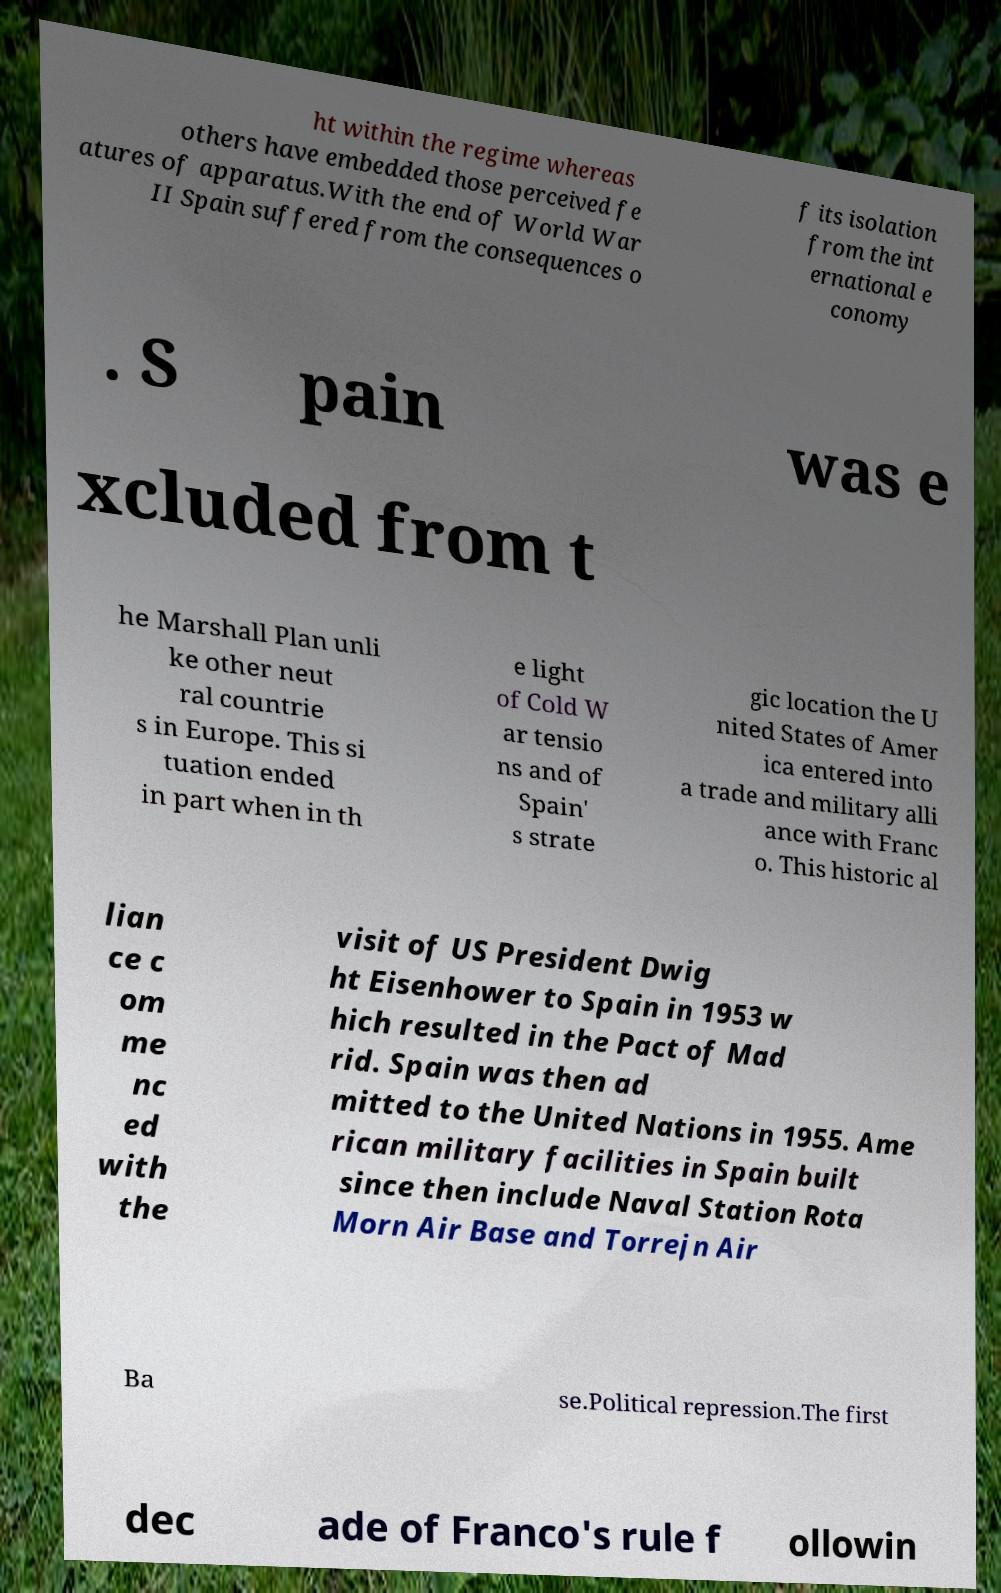Can you read and provide the text displayed in the image?This photo seems to have some interesting text. Can you extract and type it out for me? ht within the regime whereas others have embedded those perceived fe atures of apparatus.With the end of World War II Spain suffered from the consequences o f its isolation from the int ernational e conomy . S pain was e xcluded from t he Marshall Plan unli ke other neut ral countrie s in Europe. This si tuation ended in part when in th e light of Cold W ar tensio ns and of Spain' s strate gic location the U nited States of Amer ica entered into a trade and military alli ance with Franc o. This historic al lian ce c om me nc ed with the visit of US President Dwig ht Eisenhower to Spain in 1953 w hich resulted in the Pact of Mad rid. Spain was then ad mitted to the United Nations in 1955. Ame rican military facilities in Spain built since then include Naval Station Rota Morn Air Base and Torrejn Air Ba se.Political repression.The first dec ade of Franco's rule f ollowin 